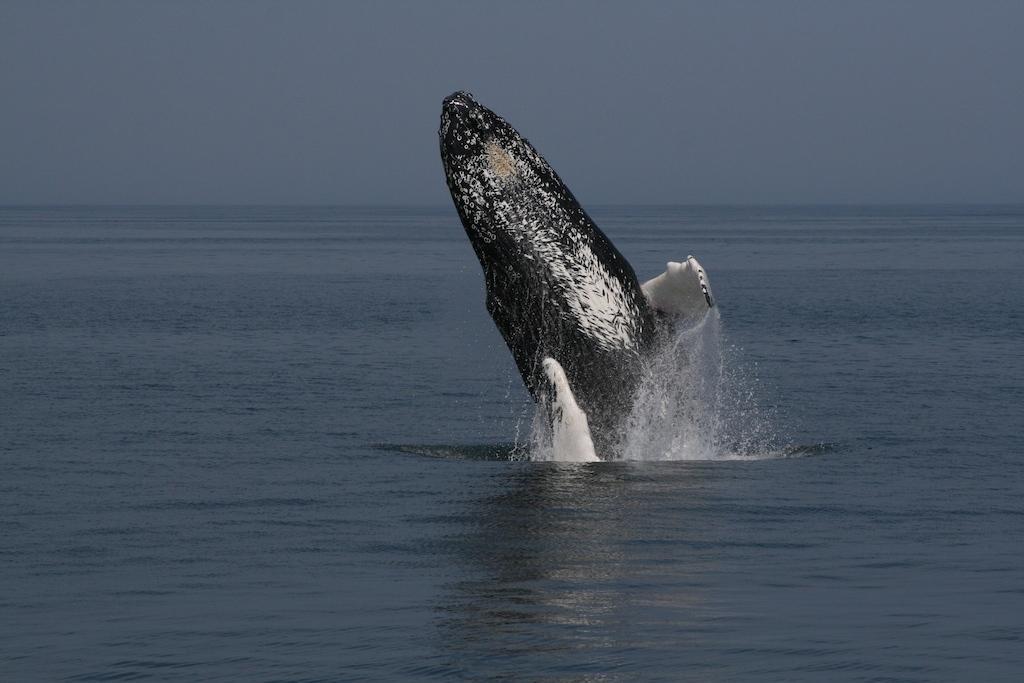In one or two sentences, can you explain what this image depicts? In this image there is a shark in the water. In the background of the image there is sky. 